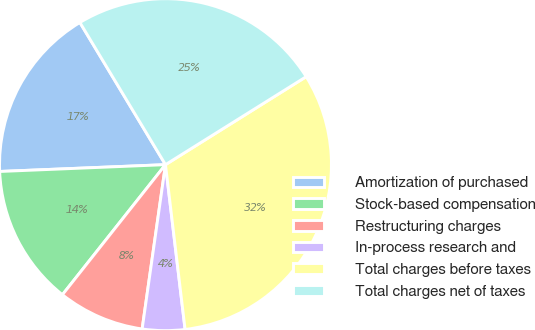<chart> <loc_0><loc_0><loc_500><loc_500><pie_chart><fcel>Amortization of purchased<fcel>Stock-based compensation<fcel>Restructuring charges<fcel>In-process research and<fcel>Total charges before taxes<fcel>Total charges net of taxes<nl><fcel>17.03%<fcel>13.68%<fcel>8.42%<fcel>4.13%<fcel>32.01%<fcel>24.73%<nl></chart> 